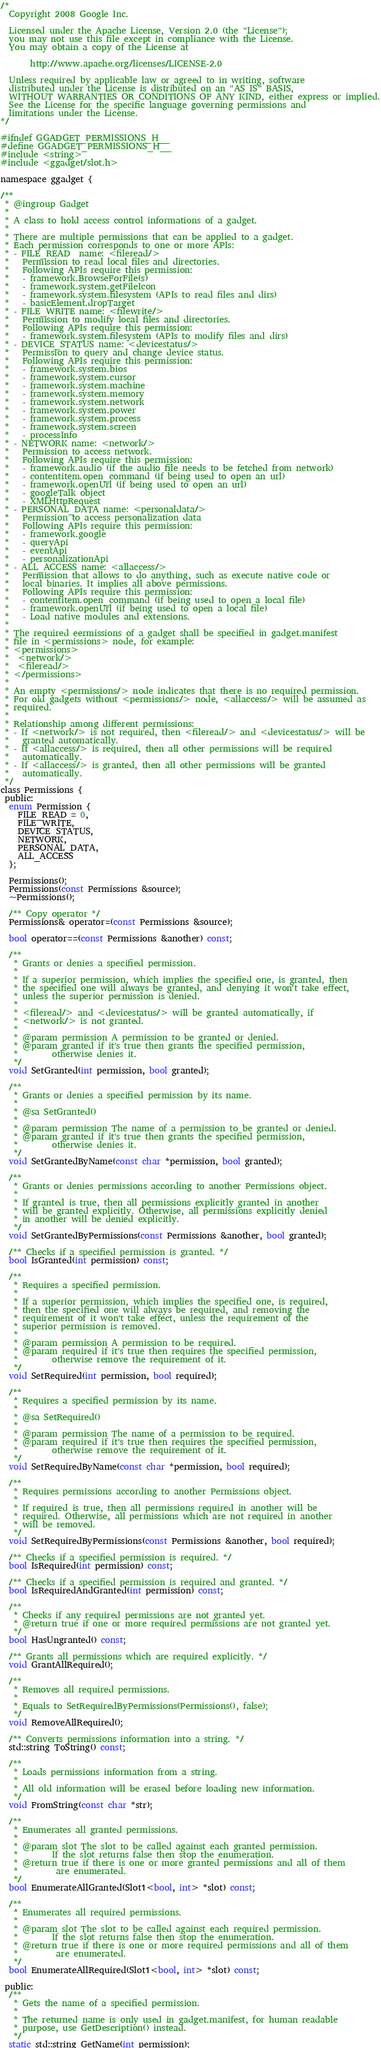Convert code to text. <code><loc_0><loc_0><loc_500><loc_500><_C_>/*
  Copyright 2008 Google Inc.

  Licensed under the Apache License, Version 2.0 (the "License");
  you may not use this file except in compliance with the License.
  You may obtain a copy of the License at

       http://www.apache.org/licenses/LICENSE-2.0

  Unless required by applicable law or agreed to in writing, software
  distributed under the License is distributed on an "AS IS" BASIS,
  WITHOUT WARRANTIES OR CONDITIONS OF ANY KIND, either express or implied.
  See the License for the specific language governing permissions and
  limitations under the License.
*/

#ifndef GGADGET_PERMISSIONS_H__
#define GGADGET_PERMISSIONS_H__
#include <string>
#include <ggadget/slot.h>

namespace ggadget {

/**
 * @ingroup Gadget
 *
 * A class to hold access control informations of a gadget.
 *
 * There are multiple permissions that can be applied to a gadget.
 * Each permission corresponds to one or more APIs:
 * - FILE_READ  name: <fileread/>
 *   Permission to read local files and directories.
 *   Following APIs require this permission:
 *   - framework.BrowseForFile(s)
 *   - framework.system.getFileIcon
 *   - framework.system.filesystem (APIs to read files and dirs)
 *   - basicElement.dropTarget
 * - FILE_WRITE name: <filewrite/>
 *   Permission to modify local files and directories.
 *   Following APIs require this permission:
 *   - framework.system.filesystem (APIs to modify files and dirs)
 * - DEVICE_STATUS name: <devicestatus/>
 *   Permission to query and change device status.
 *   Following APIs require this permission:
 *   - framework.system.bios
 *   - framework.system.cursor
 *   - framework.system.machine
 *   - framework.system.memory
 *   - framework.system.network
 *   - framework.system.power
 *   - framework.system.process
 *   - framework.system.screen
 *   - processInfo
 * - NETWORK name: <network/>
 *   Permission to access network.
 *   Following APIs require this permission:
 *   - framework.audio (if the audio file needs to be fetched from network)
 *   - contentitem.open_command (if being used to open an url)
 *   - framework.openUrl (if being used to open an url)
 *   - googleTalk object
 *   - XMLHttpRequest
 * - PERSONAL_DATA name: <personaldata/>
 *   Permission to access personalization data
 *   Following APIs require this permission:
 *   - framework.google
 *   - queryApi
 *   - eventApi
 *   - personalizationApi
 * - ALL_ACCESS name: <allaccess/>
 *   Permission that allows to do anything, such as execute native code or
 *   local binaries. It implies all above permissions.
 *   Following APIs require this permission:
 *   - contentitem.open_command (if being used to open a local file)
 *   - framework.openUrl (if being used to open a local file)
 *   - Load native modules and extensions.
 *
 * The required eermissions of a gadget shall be specified in gadget.manifest
 * file in <permissions> node, for example:
 * <permissions>
 *  <network/>
 *  <fileread/>
 * </permissions>
 *
 * An empty <permissions/> node indicates that there is no required permission.
 * For old gadgets without <permissions/> node, <allaccess/> will be assumed as
 * required.
 *
 * Relationship among different permissions:
 * - If <network/> is not required, then <fileread/> and <devicestatus/> will be
 *   granted automatically.
 * - If <allaccess/> is required, then all other permissions will be required
 *   automatically.
 * - If <allaccess/> is granted, then all other permissions will be granted
 *   automatically.
 */
class Permissions {
 public:
  enum Permission {
    FILE_READ = 0,
    FILE_WRITE,
    DEVICE_STATUS,
    NETWORK,
    PERSONAL_DATA,
    ALL_ACCESS
  };

  Permissions();
  Permissions(const Permissions &source);
  ~Permissions();

  /** Copy operator */
  Permissions& operator=(const Permissions &source);

  bool operator==(const Permissions &another) const;

  /**
   * Grants or denies a specified permission.
   *
   * If a superior permission, which implies the specified one, is granted, then
   * the specified one will always be granted, and denying it won't take effect,
   * unless the superior permission is denied.
   *
   * <fileread/> and <devicestatus/> will be granted automatically, if
   * <network/> is not granted.
   *
   * @param permission A permission to be granted or denied.
   * @param granted if it's true then grants the specified permission,
   *        otherwise denies it.
   */
  void SetGranted(int permission, bool granted);

  /**
   * Grants or denies a specified permission by its name.
   *
   * @sa SetGranted()
   *
   * @param permission The name of a permission to be granted or denied.
   * @param granted if it's true then grants the specified permission,
   *        otherwise denies it.
   */
  void SetGrantedByName(const char *permission, bool granted);

  /**
   * Grants or denies permissions according to another Permissions object.
   *
   * If granted is true, then all permissions explicitly granted in another
   * will be granted explicitly. Otherwise, all permissions explicitly denied
   * in another will be denied explicitly.
   */
  void SetGrantedByPermissions(const Permissions &another, bool granted);

  /** Checks if a specified permission is granted. */
  bool IsGranted(int permission) const;

  /**
   * Requires a specified permission.
   *
   * If a superior permission, which implies the specified one, is required,
   * then the specified one will always be required, and removing the
   * requirement of it won't take effect, unless the requirement of the
   * superior permission is removed.
   *
   * @param permission A permission to be required.
   * @param required if it's true then requires the specified permission,
   *        otherwise remove the requirement of it.
   */
  void SetRequired(int permission, bool required);

  /**
   * Requires a specified permission by its name.
   *
   * @sa SetRequired()
   *
   * @param permission The name of a permission to be required.
   * @param required if it's true then requires the specified permission,
   *        otherwise remove the requirement of it.
   */
  void SetRequiredByName(const char *permission, bool required);

  /**
   * Requires permissions according to another Permissions object.
   *
   * If required is true, then all permissions required in another will be
   * required. Otherwise, all permissions which are not required in another
   * will be removed.
   */
  void SetRequiredByPermissions(const Permissions &another, bool required);

  /** Checks if a specified permission is required. */
  bool IsRequired(int permission) const;

  /** Checks if a specified permission is required and granted. */
  bool IsRequiredAndGranted(int permission) const;

  /**
   * Checks if any required permissions are not granted yet.
   * @return true if one or more required permissions are not granted yet.
   */
  bool HasUngranted() const;

  /** Grants all permissions which are required explicitly. */
  void GrantAllRequired();

  /**
   * Removes all required permissions.
   *
   * Equals to SetRequiredByPermissions(Permissions(), false);
   */
  void RemoveAllRequired();

  /** Converts permissions information into a string. */
  std::string ToString() const;

  /**
   * Loads permissions information from a string.
   *
   * All old information will be erased before loading new information.
   */
  void FromString(const char *str);

  /**
   * Enumerates all granted permissions.
   *
   * @param slot The slot to be called against each granted permission.
   *        If the slot returns false then stop the enumeration.
   * @return true if there is one or more granted permissions and all of them
   *         are enumerated.
   */
  bool EnumerateAllGranted(Slot1<bool, int> *slot) const;

  /**
   * Enumerates all required permissions.
   *
   * @param slot The slot to be called against each required permission.
   *        If the slot returns false then stop the enumeration.
   * @return true if there is one or more required permissions and all of them
   *         are enumerated.
   */
  bool EnumerateAllRequired(Slot1<bool, int> *slot) const;

 public:
  /**
   * Gets the name of a specified permission.
   *
   * The returned name is only used in gadget.manifest, for human readable
   * purpose, use GetDescription() instead.
   */
  static std::string GetName(int permission);
</code> 